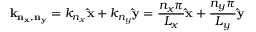Convert formula to latex. <formula><loc_0><loc_0><loc_500><loc_500>k _ { n _ { x } , n _ { y } } = k _ { n _ { x } } \hat { x } + k _ { n _ { y } } \hat { y } = { \frac { n _ { x } \pi } { L _ { x } } } \hat { x } + { \frac { n _ { y } \pi } { L _ { y } } } \hat { y }</formula> 